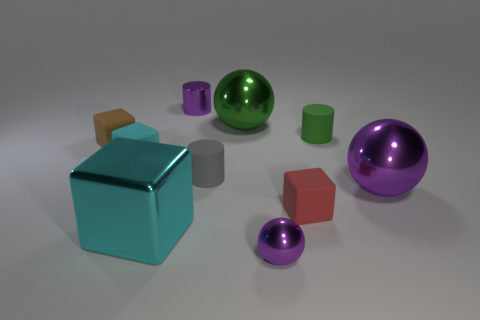What is the material of the other cube that is the same color as the metal block?
Your answer should be very brief. Rubber. What is the material of the tiny cylinder that is both in front of the purple cylinder and left of the green rubber cylinder?
Provide a short and direct response. Rubber. Does the large thing that is left of the small purple metallic cylinder have the same material as the cyan cube behind the red object?
Your response must be concise. No. There is a tiny gray thing that is the same shape as the green matte object; what is it made of?
Your answer should be very brief. Rubber. Do the tiny rubber object in front of the big purple shiny ball and the tiny object that is on the left side of the cyan rubber thing have the same shape?
Make the answer very short. Yes. Are there more tiny green rubber objects than gray metal cubes?
Make the answer very short. Yes. What size is the green metallic sphere?
Offer a terse response. Large. What number of other objects are the same color as the large block?
Your answer should be very brief. 1. Is the cyan block behind the big cyan cube made of the same material as the gray cylinder?
Offer a terse response. Yes. Is the number of green cylinders that are left of the red rubber object less than the number of purple shiny things behind the big cyan object?
Ensure brevity in your answer.  Yes. 